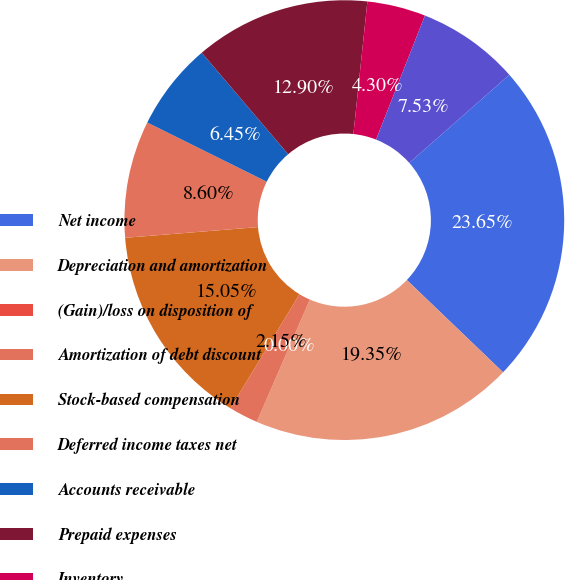<chart> <loc_0><loc_0><loc_500><loc_500><pie_chart><fcel>Net income<fcel>Depreciation and amortization<fcel>(Gain)/loss on disposition of<fcel>Amortization of debt discount<fcel>Stock-based compensation<fcel>Deferred income taxes net<fcel>Accounts receivable<fcel>Prepaid expenses<fcel>Inventory<fcel>Deposits and other assets<nl><fcel>23.65%<fcel>19.35%<fcel>0.0%<fcel>2.15%<fcel>15.05%<fcel>8.6%<fcel>6.45%<fcel>12.9%<fcel>4.3%<fcel>7.53%<nl></chart> 